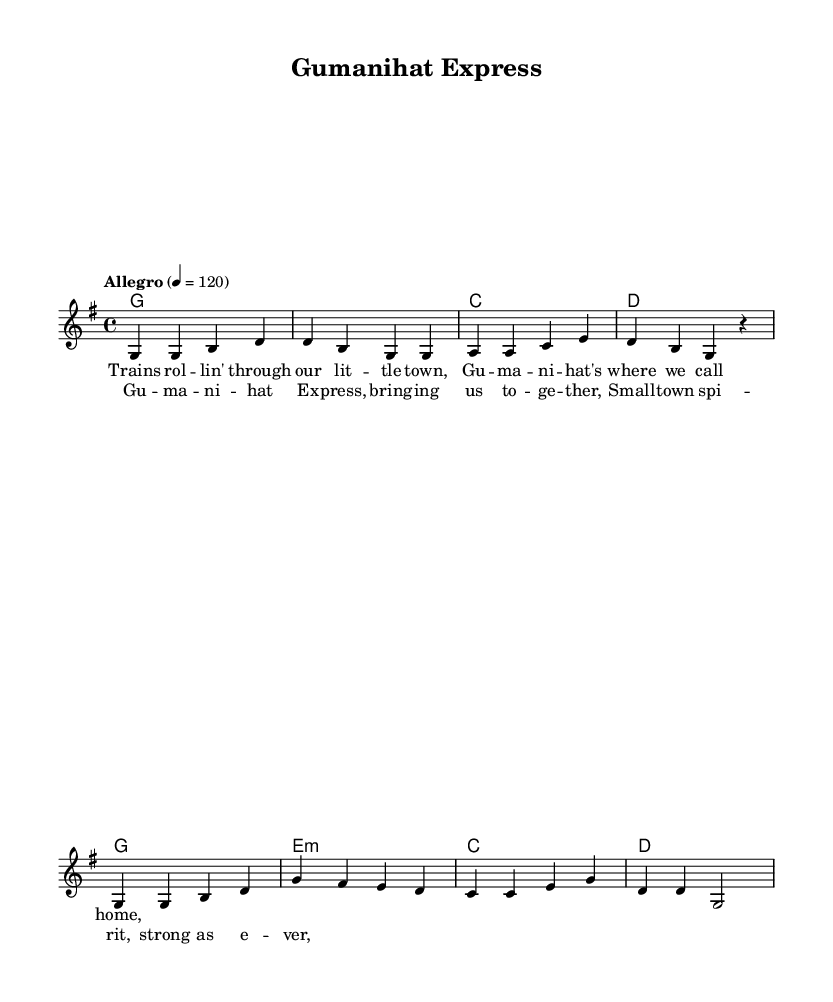What is the key signature of this music? The key signature is G major, which has one sharp (F#). This can be determined by looking at the key signature indicated at the beginning of the sheet music.
Answer: G major What is the time signature of this music? The time signature is 4/4, which is indicated at the beginning of the sheet music. It shows that there are four beats in each measure and the quarter note gets one beat.
Answer: 4/4 What is the tempo marking for this music? The tempo marking is "Allegro" and indicates a speed of 120 beats per minute. This reflects the lively and upbeat nature typical of country music.
Answer: Allegro What chords are used in the verse? The chords used in the verse are G, C, and D. These can be identified in the harmonies section under the verse part.
Answer: G, C, D What is the main theme of the lyrics in the chorus? The main theme of the lyrics in the chorus is community spirit. The lyrics emphasize togetherness, common in country music reflecting small-town life.
Answer: Community spirit How many measures are in the verse? There are four measures in the verse, as indicated by the grouping of notes and the aligned chord symbols above them.
Answer: 4 What is the last note of the melody in the chorus? The last note of the melody in the chorus is G. This note is noted in the last measure of the melody section of the chorus.
Answer: G 